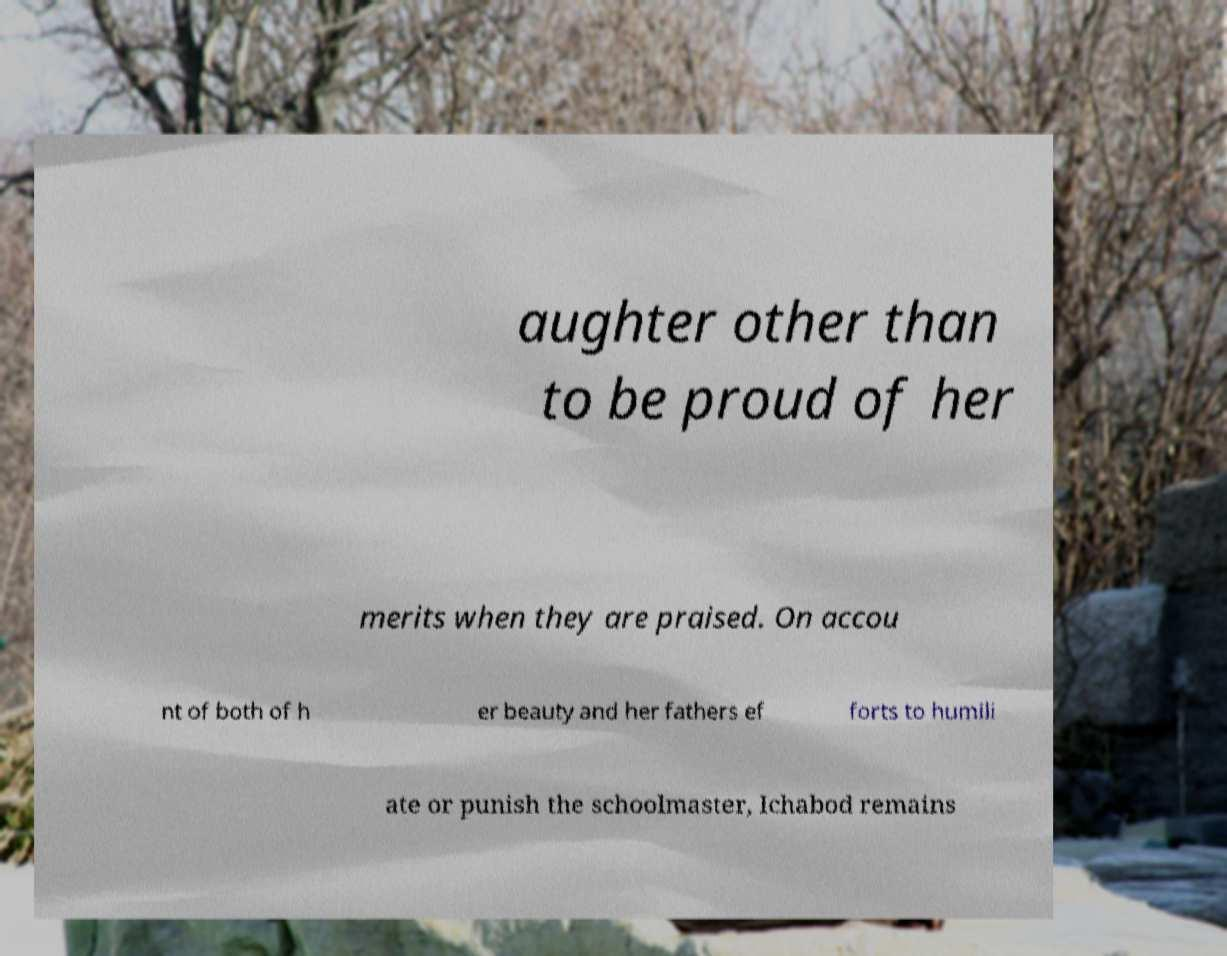Could you extract and type out the text from this image? aughter other than to be proud of her merits when they are praised. On accou nt of both of h er beauty and her fathers ef forts to humili ate or punish the schoolmaster, Ichabod remains 